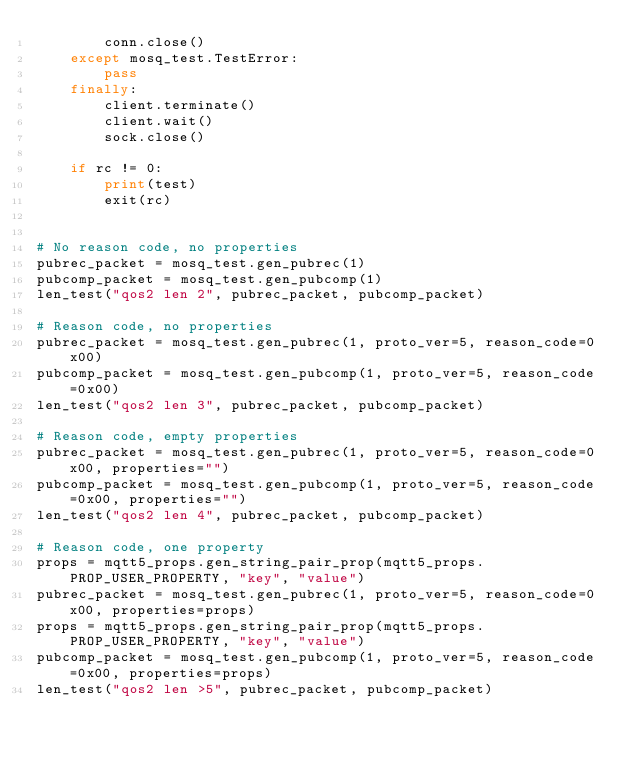<code> <loc_0><loc_0><loc_500><loc_500><_Python_>        conn.close()
    except mosq_test.TestError:
        pass
    finally:
        client.terminate()
        client.wait()
        sock.close()

    if rc != 0:
        print(test)
        exit(rc)


# No reason code, no properties
pubrec_packet = mosq_test.gen_pubrec(1)
pubcomp_packet = mosq_test.gen_pubcomp(1)
len_test("qos2 len 2", pubrec_packet, pubcomp_packet)

# Reason code, no properties
pubrec_packet = mosq_test.gen_pubrec(1, proto_ver=5, reason_code=0x00)
pubcomp_packet = mosq_test.gen_pubcomp(1, proto_ver=5, reason_code=0x00)
len_test("qos2 len 3", pubrec_packet, pubcomp_packet)

# Reason code, empty properties
pubrec_packet = mosq_test.gen_pubrec(1, proto_ver=5, reason_code=0x00, properties="")
pubcomp_packet = mosq_test.gen_pubcomp(1, proto_ver=5, reason_code=0x00, properties="")
len_test("qos2 len 4", pubrec_packet, pubcomp_packet)

# Reason code, one property
props = mqtt5_props.gen_string_pair_prop(mqtt5_props.PROP_USER_PROPERTY, "key", "value")
pubrec_packet = mosq_test.gen_pubrec(1, proto_ver=5, reason_code=0x00, properties=props)
props = mqtt5_props.gen_string_pair_prop(mqtt5_props.PROP_USER_PROPERTY, "key", "value")
pubcomp_packet = mosq_test.gen_pubcomp(1, proto_ver=5, reason_code=0x00, properties=props)
len_test("qos2 len >5", pubrec_packet, pubcomp_packet)
</code> 